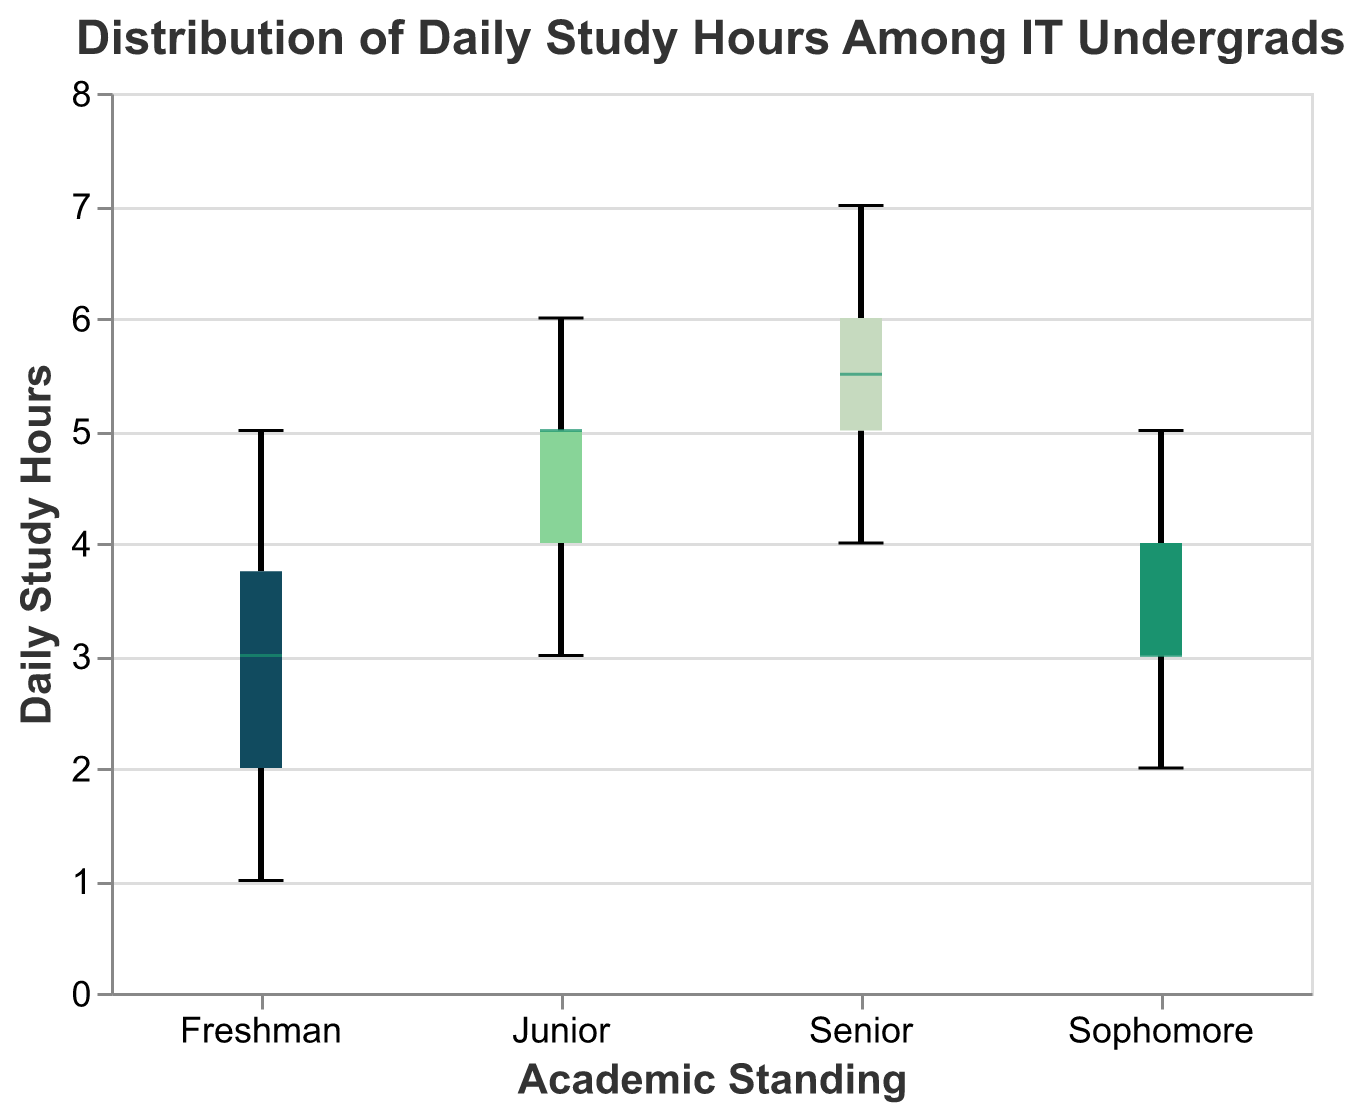What's the title of the plot? The title is clearly displayed at the top of the plot in a large font, making it easy to read.
Answer: Distribution of Daily Study Hours Among IT Undergrads What is the range of daily study hours for Sophomores? The box plot shows the minimum and maximum values for each group. For Sophomores, the range is between the lowest and highest points in the box plot for this group.
Answer: 2 to 5 hours Which academic standing group has the highest median daily study hours? The median is shown as a distinct line within each box. By comparing the medians for all groups, the highest one can be identified.
Answer: Seniors How do the interquartile ranges (IQR) of Juniors and Seniors compare? The IQR is represented by the box in each box plot, which spans from Q1 (25th percentile) to Q3 (75th percentile). By visually comparing the lengths of the boxes for Juniors and Seniors, we can determine that Seniors have a wider IQR.
Answer: Seniors have a wider IQR What's the median daily study hours for Freshmen? The median is the line inside the box of the box plot for Freshmen.
Answer: 3 hours Which group has the widest range of daily study hours? The widest range can be identified by observing the span from the minimum to the maximum value (whiskers) in each box plot.
Answer: Juniors How many groups have a median daily study hours of 5 or more? The question can be answered by counting the number of groups where the median line in the box plot is at or above 5 hours.
Answer: Three groups What is the difference between the upper quartile of Sophomores and Juniors? The upper quartile (Q3) can be found at the top boundary of each box. By noting the values, the difference can be calculated.
Answer: 1 hour (4 for Sophomores, 5 for Juniors) Which academic standing group has the lowest maximum daily study hours? The maximum value is indicated by the top whisker in each box plot. By comparing these whiskers, the lowest maximum can be identified.
Answer: Freshmen Do Seniors have any outliers in their study hours? Outliers in a box plot are typically marked with dots. Checking the plot for Seniors reveals whether such dots are present.
Answer: No 